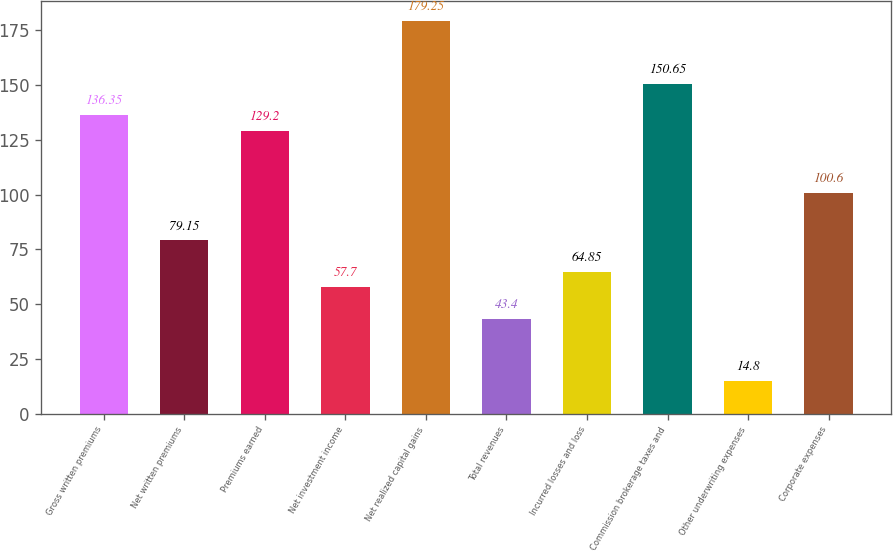Convert chart. <chart><loc_0><loc_0><loc_500><loc_500><bar_chart><fcel>Gross written premiums<fcel>Net written premiums<fcel>Premiums earned<fcel>Net investment income<fcel>Net realized capital gains<fcel>Total revenues<fcel>Incurred losses and loss<fcel>Commission brokerage taxes and<fcel>Other underwriting expenses<fcel>Corporate expenses<nl><fcel>136.35<fcel>79.15<fcel>129.2<fcel>57.7<fcel>179.25<fcel>43.4<fcel>64.85<fcel>150.65<fcel>14.8<fcel>100.6<nl></chart> 